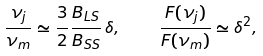<formula> <loc_0><loc_0><loc_500><loc_500>\frac { \nu _ { j } } { \nu _ { m } } \simeq \frac { 3 } { 2 } \frac { B _ { L S } } { B _ { S S } } \, \delta , \quad \frac { F ( \nu _ { j } ) } { F ( \nu _ { m } ) } \simeq \delta ^ { 2 } ,</formula> 